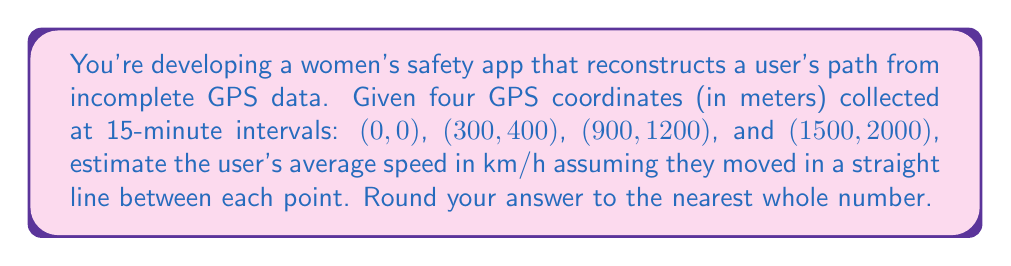Solve this math problem. 1) First, calculate the distances between consecutive points using the distance formula:
   $d = \sqrt{(x_2-x_1)^2 + (y_2-y_1)^2}$

   Point 1 to 2: $d_1 = \sqrt{(300-0)^2 + (400-0)^2} = 500$ m
   Point 2 to 3: $d_2 = \sqrt{(900-300)^2 + (1200-400)^2} = 1000$ m
   Point 3 to 4: $d_3 = \sqrt{(1500-900)^2 + (2000-1200)^2} = 1000$ m

2) Total distance: $d_{total} = 500 + 1000 + 1000 = 2500$ m

3) Total time: 3 intervals of 15 minutes each = 45 minutes = 0.75 hours

4) Average speed: $v = \frac{d_{total}}{t}$
   $v = \frac{2500 \text{ m}}{0.75 \text{ h}} = 3333.33 \text{ m/h}$

5) Convert to km/h:
   $v = 3333.33 \text{ m/h} \times \frac{1 \text{ km}}{1000 \text{ m}} = 3.33 \text{ km/h}$

6) Rounding to the nearest whole number: 3 km/h
Answer: 3 km/h 